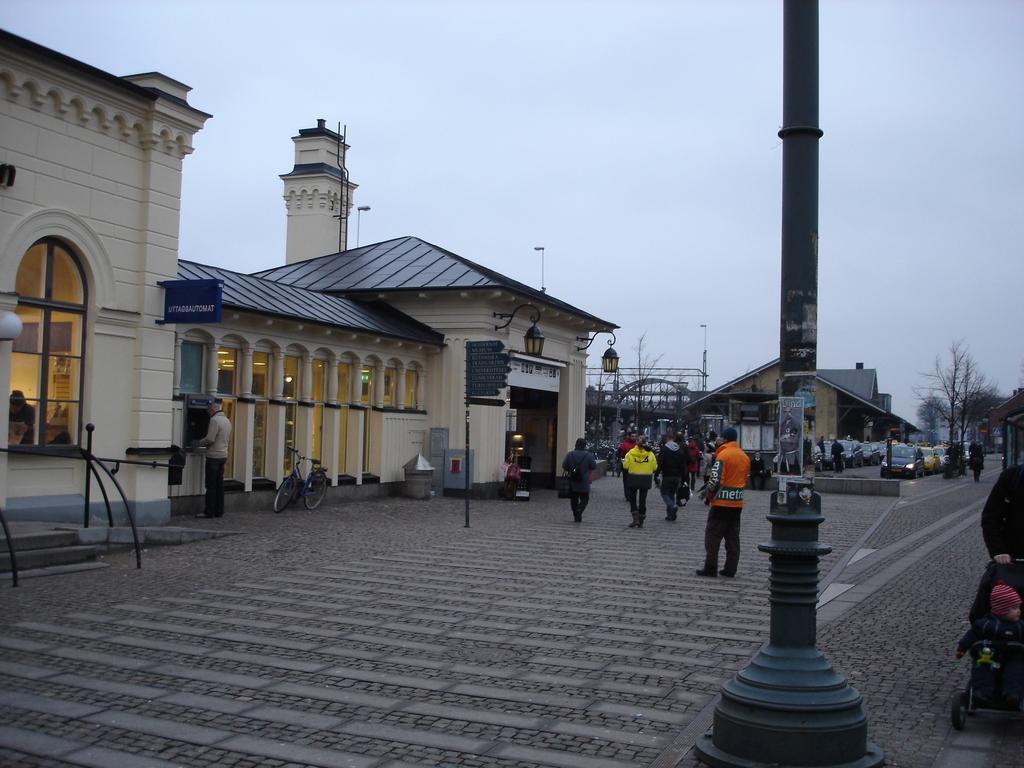How would you summarize this image in a sentence or two? In this picture we can see people and vehicles on the road, here we can see a bicycle, buildings, trees, lights and few objects and in the background we can see the sky. 